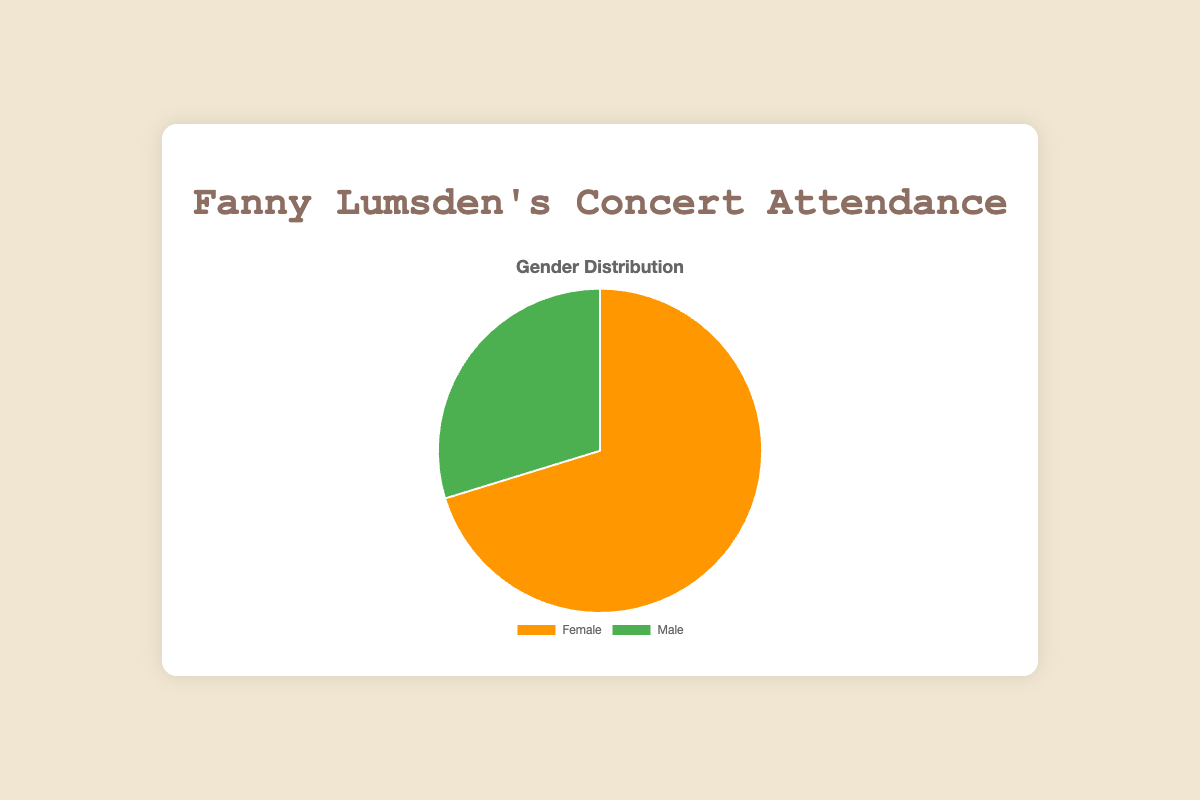What is the total attendance at Fanny Lumsden's concerts based on the gender distribution shown in the chart? To find the total attendance, we add the number of female attendees (1405) to the number of male attendees (595). Therefore, 1405 + 595 = 2000.
Answer: 2000 Which gender had a higher attendance at Fanny Lumsden's concerts? By looking at the pie chart, the section representing females is larger than the section representing males, indicating higher attendance for females.
Answer: Female What percentage of the attendees were male? To find the percentage of male attendees, divide the number of male attendees (595) by the total attendance (2000) and multiply by 100. So, (595 / 2000) * 100 = 29.75%.
Answer: 29.75% How much larger is the female attendance compared to the male attendance? Subtract the number of male attendees (595) from the number of female attendees (1405). So, 1405 - 595 = 810.
Answer: 810 What color represents female attendees in the pie chart? Based on the color legend, the section for female attendees is represented in orange while the section for male attendees is represented in green.
Answer: Orange If the pattern in gender attendance continues, what can be inferred about the expected female and male attendance at future concerts? Given the consistent data showing significantly higher female attendance, it is reasonable to infer that future attendance will also likely have higher female attendance compared to male attendance.
Answer: Higher female attendance Comparing the size of the segments in the pie chart visually, which segment is more than twice as large as the other? By comparing the segments, the female segment is more than twice the size of the male segment.
Answer: Female segment What is the overall ratio of female to male attendees at the concerts? To find the ratio, divide the number of female attendees (1405) by the number of male attendees (595). So, the ratio is 1405:595. Simplified, it is approximately 2.36:1.
Answer: 2.36:1 How would you describe the balance of male and female attendees based on the visual attributes of the pie chart? The pie chart visually shows an imbalance, with the female section being significantly larger than the male section, indicating a higher proportion of female attendees.
Answer: Imbalance with more female attendees 